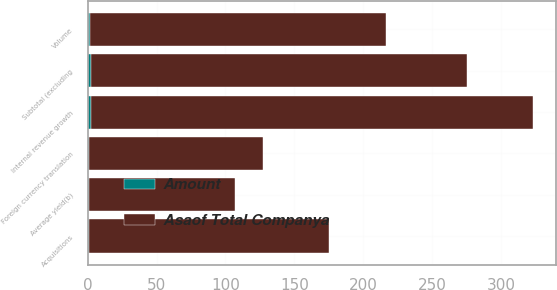Convert chart. <chart><loc_0><loc_0><loc_500><loc_500><stacked_bar_chart><ecel><fcel>Average yield(b)<fcel>Volume<fcel>Internal revenue growth<fcel>Acquisitions<fcel>Foreign currency translation<fcel>Subtotal (excluding<nl><fcel>Asaof Total Companya<fcel>106<fcel>215<fcel>321<fcel>174<fcel>126<fcel>273<nl><fcel>Amount<fcel>0.8<fcel>1.6<fcel>2.4<fcel>1.3<fcel>1<fcel>2.1<nl></chart> 